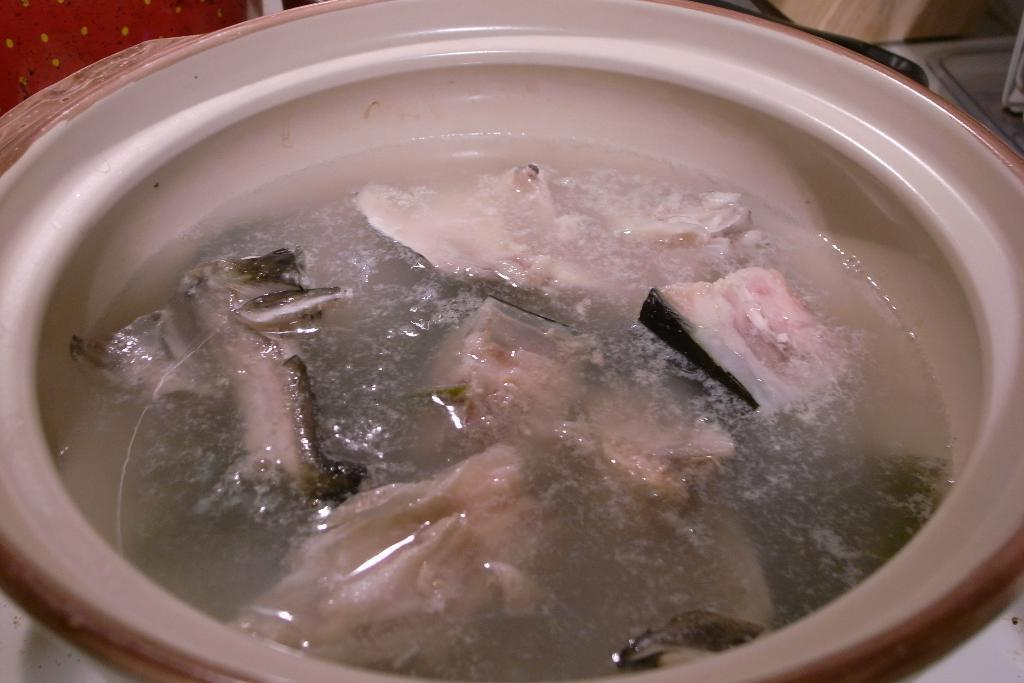What is in the bowl that is visible in the image? The bowl contains soup. Can you describe the contents of the bowl in more detail? The bowl contains soup, which suggests it might be a warm and savory dish. Where is the faucet located in the image? There is no faucet present in the image. What type of dolls are sitting around the bowl in the image? There are no dolls present in the image. 